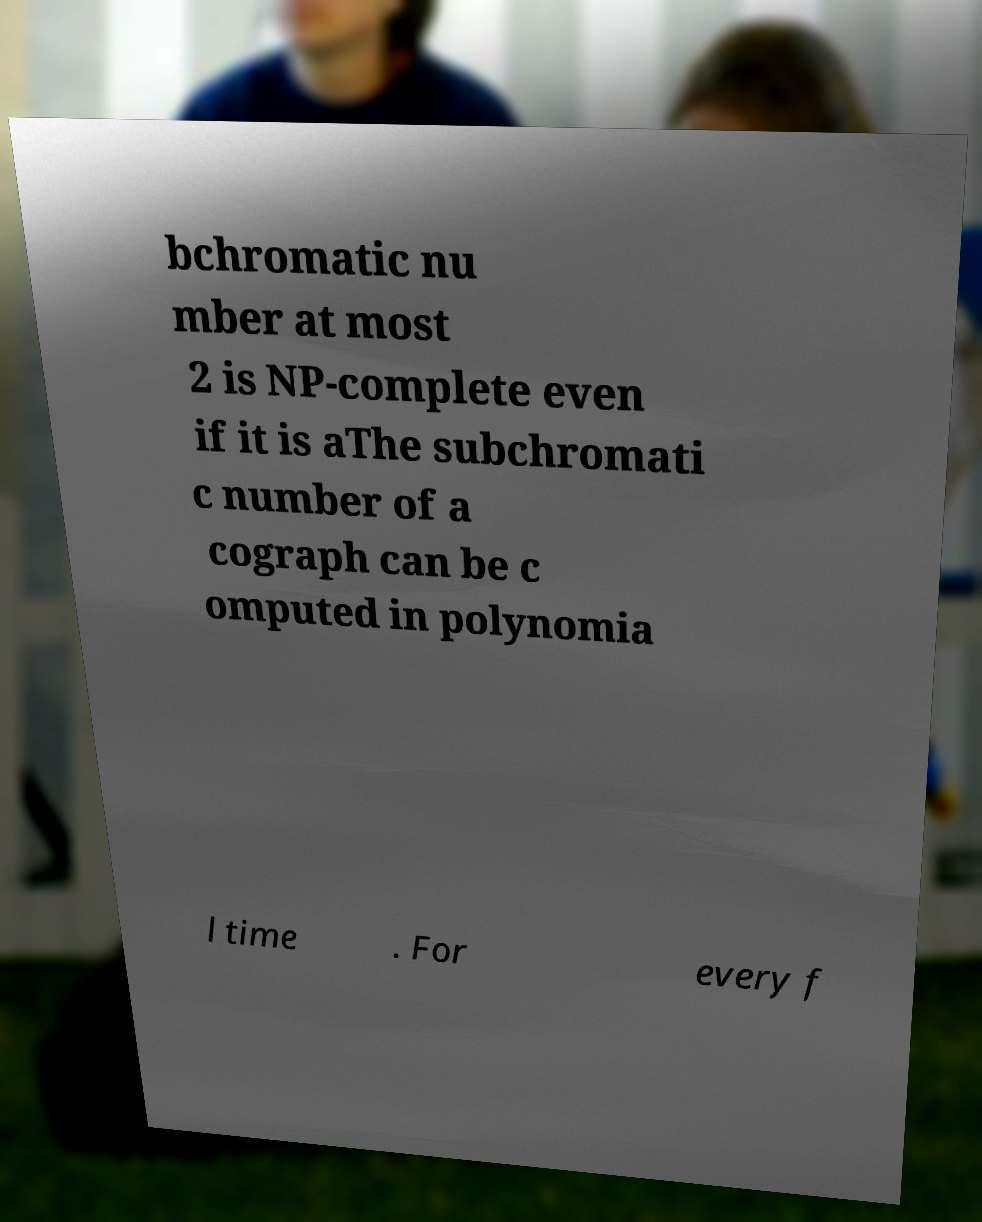There's text embedded in this image that I need extracted. Can you transcribe it verbatim? bchromatic nu mber at most 2 is NP-complete even if it is aThe subchromati c number of a cograph can be c omputed in polynomia l time . For every f 